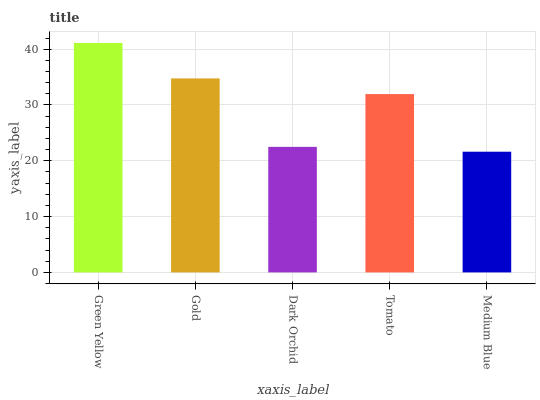Is Gold the minimum?
Answer yes or no. No. Is Gold the maximum?
Answer yes or no. No. Is Green Yellow greater than Gold?
Answer yes or no. Yes. Is Gold less than Green Yellow?
Answer yes or no. Yes. Is Gold greater than Green Yellow?
Answer yes or no. No. Is Green Yellow less than Gold?
Answer yes or no. No. Is Tomato the high median?
Answer yes or no. Yes. Is Tomato the low median?
Answer yes or no. Yes. Is Green Yellow the high median?
Answer yes or no. No. Is Green Yellow the low median?
Answer yes or no. No. 